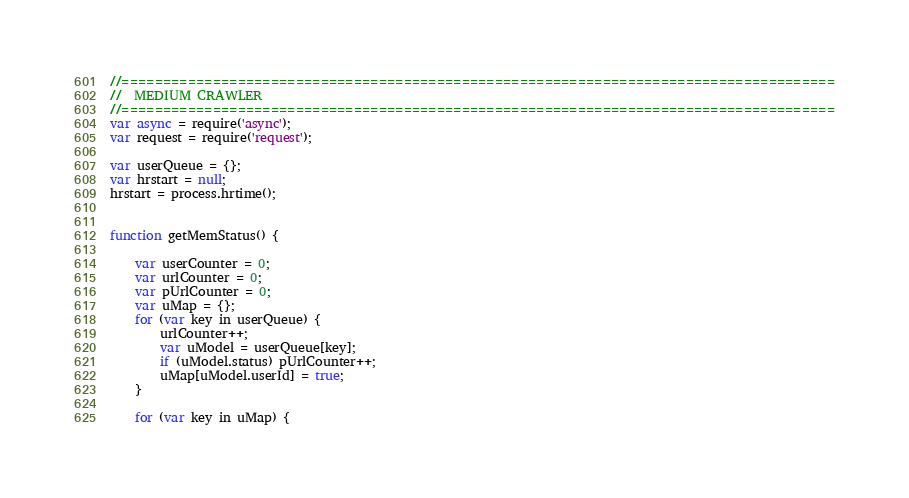Convert code to text. <code><loc_0><loc_0><loc_500><loc_500><_JavaScript_>//======================================================================================
//  MEDIUM CRAWLER
//======================================================================================
var async = require('async');
var request = require('request');

var userQueue = {};
var hrstart = null;
hrstart = process.hrtime();


function getMemStatus() {

    var userCounter = 0;
    var urlCounter = 0;
    var pUrlCounter = 0;
    var uMap = {};
    for (var key in userQueue) {
        urlCounter++;
        var uModel = userQueue[key];
        if (uModel.status) pUrlCounter++;
        uMap[uModel.userId] = true;
    }

    for (var key in uMap) {</code> 